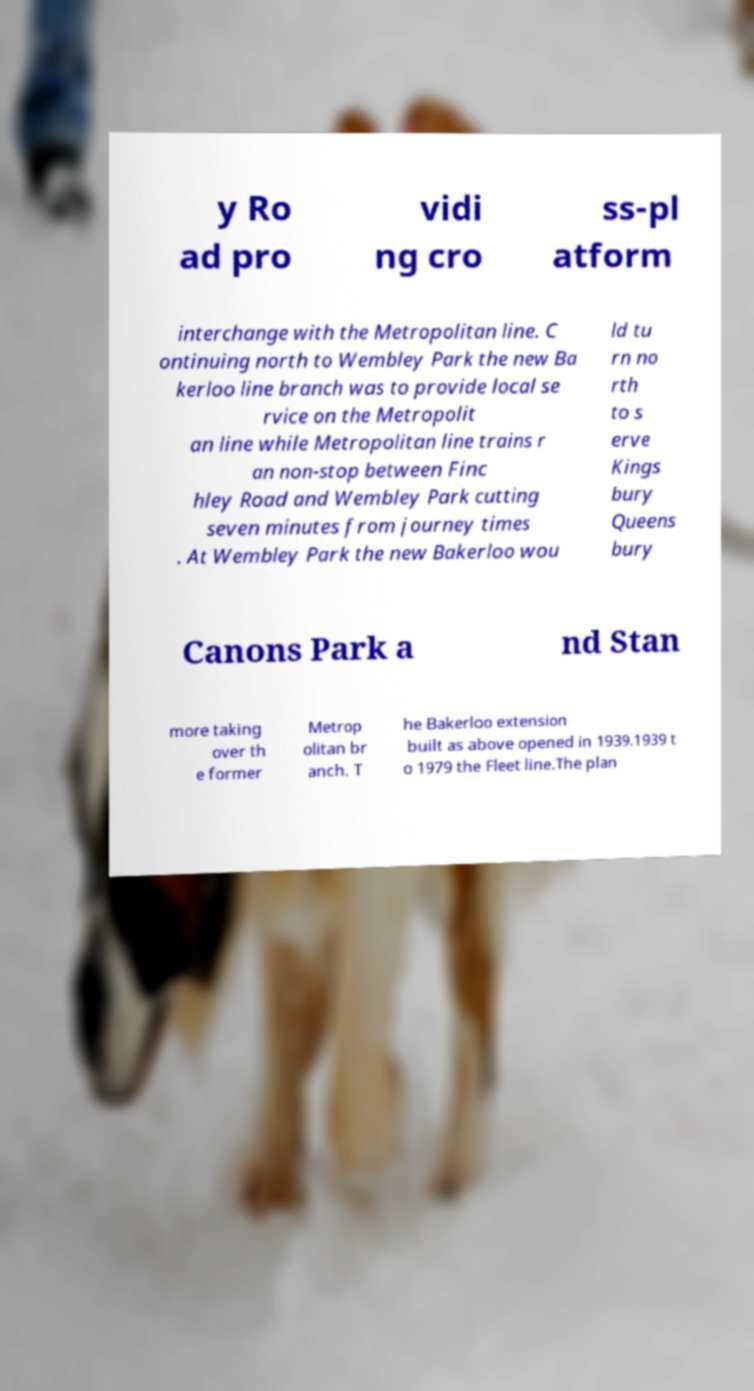For documentation purposes, I need the text within this image transcribed. Could you provide that? y Ro ad pro vidi ng cro ss-pl atform interchange with the Metropolitan line. C ontinuing north to Wembley Park the new Ba kerloo line branch was to provide local se rvice on the Metropolit an line while Metropolitan line trains r an non-stop between Finc hley Road and Wembley Park cutting seven minutes from journey times . At Wembley Park the new Bakerloo wou ld tu rn no rth to s erve Kings bury Queens bury Canons Park a nd Stan more taking over th e former Metrop olitan br anch. T he Bakerloo extension built as above opened in 1939.1939 t o 1979 the Fleet line.The plan 